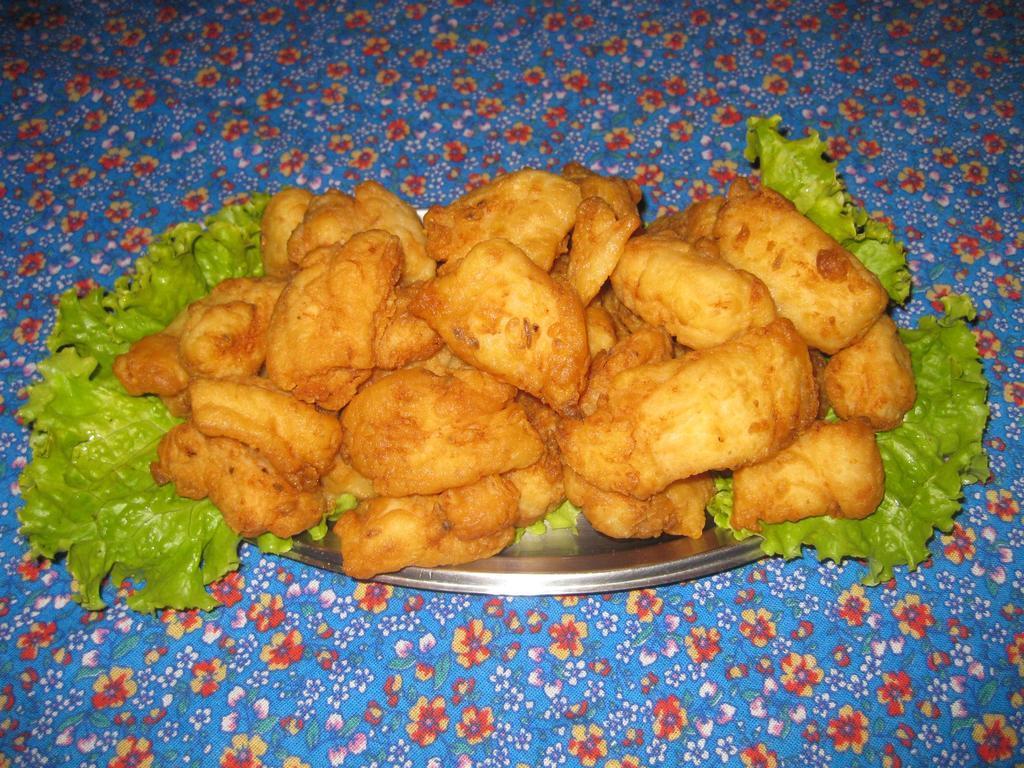Describe this image in one or two sentences. In the center of the image, we can see snacks and there are leaves on the plate. At the bottom, there is table. 